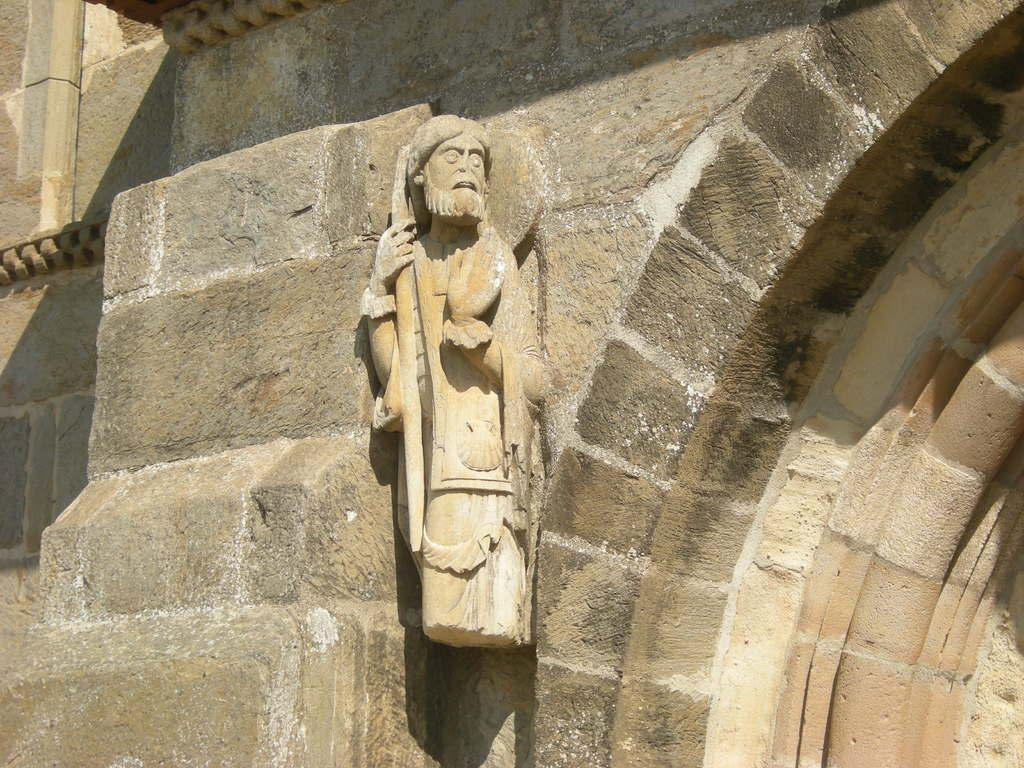What is the main subject in the foreground of the image? There is a stone sculpture in the foreground of the image. Where is the stone sculpture located in relation to other elements in the image? The stone sculpture is against a wall. What architectural feature can be seen on the right side of the image? There appears to be an arch on the right side of the image. What type of glue is being used to hold the stone sculpture together in the image? There is no indication in the image that the stone sculpture is being held together with glue, as it is likely a solid, carved piece. 